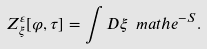Convert formula to latex. <formula><loc_0><loc_0><loc_500><loc_500>Z _ { \xi } ^ { \varepsilon } [ \varphi , \tau ] = \int D \xi \ m a t h e ^ { - S } .</formula> 